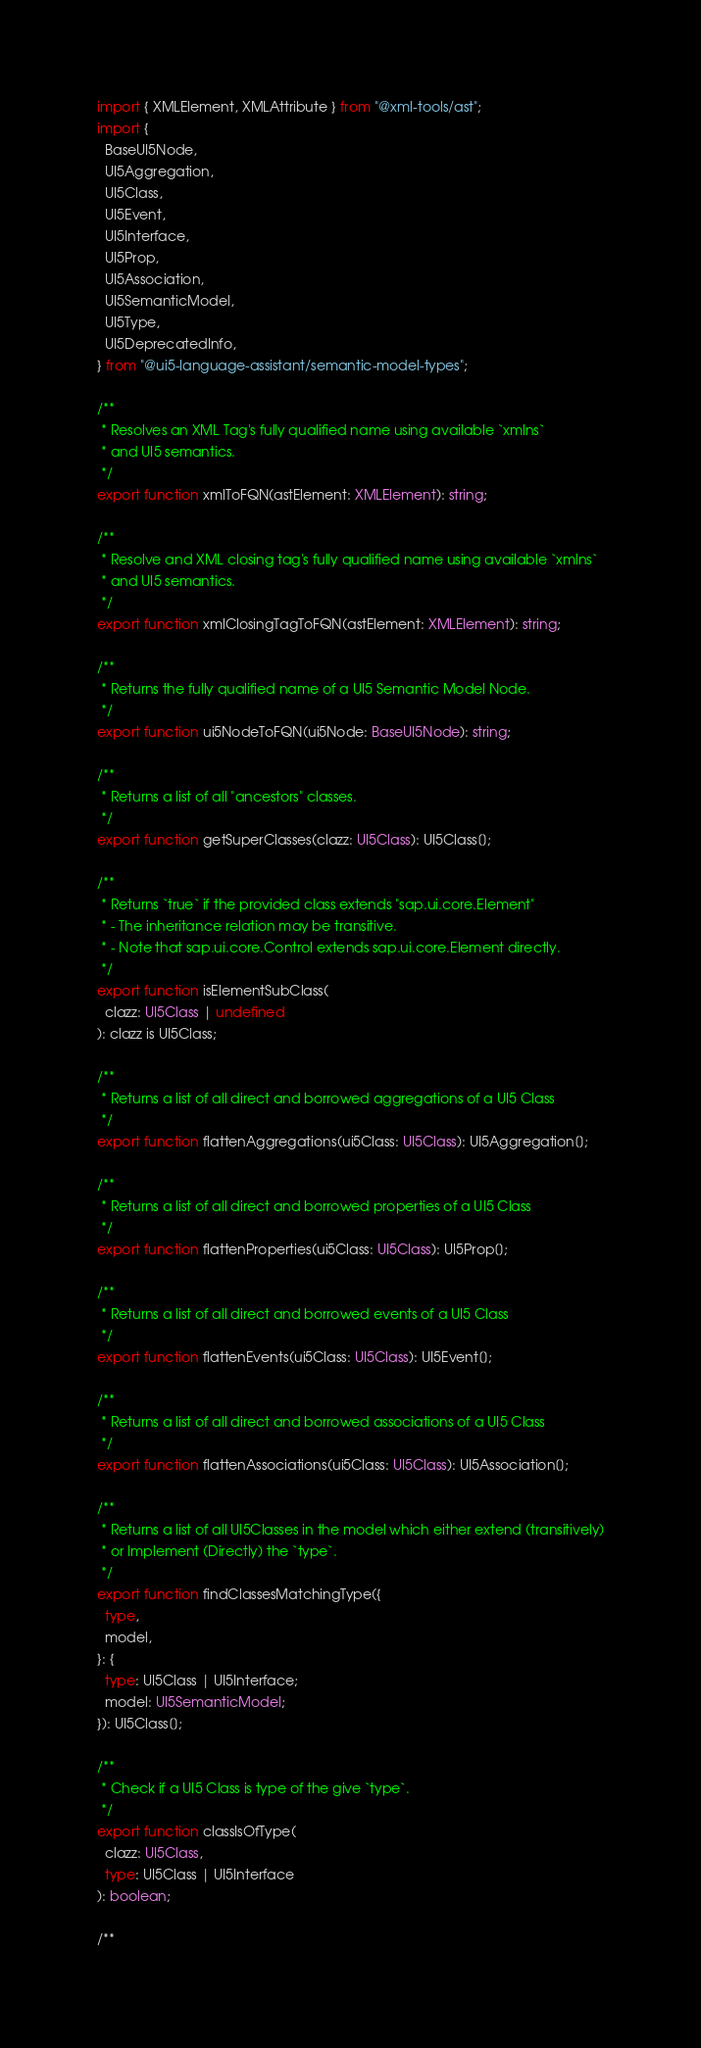<code> <loc_0><loc_0><loc_500><loc_500><_TypeScript_>import { XMLElement, XMLAttribute } from "@xml-tools/ast";
import {
  BaseUI5Node,
  UI5Aggregation,
  UI5Class,
  UI5Event,
  UI5Interface,
  UI5Prop,
  UI5Association,
  UI5SemanticModel,
  UI5Type,
  UI5DeprecatedInfo,
} from "@ui5-language-assistant/semantic-model-types";

/**
 * Resolves an XML Tag's fully qualified name using available `xmlns`
 * and UI5 semantics.
 */
export function xmlToFQN(astElement: XMLElement): string;

/**
 * Resolve and XML closing tag's fully qualified name using available `xmlns`
 * and UI5 semantics.
 */
export function xmlClosingTagToFQN(astElement: XMLElement): string;

/**
 * Returns the fully qualified name of a UI5 Semantic Model Node.
 */
export function ui5NodeToFQN(ui5Node: BaseUI5Node): string;

/**
 * Returns a list of all "ancestors" classes.
 */
export function getSuperClasses(clazz: UI5Class): UI5Class[];

/**
 * Returns `true` if the provided class extends "sap.ui.core.Element"
 * - The inheritance relation may be transitive.
 * - Note that sap.ui.core.Control extends sap.ui.core.Element directly.
 */
export function isElementSubClass(
  clazz: UI5Class | undefined
): clazz is UI5Class;

/**
 * Returns a list of all direct and borrowed aggregations of a UI5 Class
 */
export function flattenAggregations(ui5Class: UI5Class): UI5Aggregation[];

/**
 * Returns a list of all direct and borrowed properties of a UI5 Class
 */
export function flattenProperties(ui5Class: UI5Class): UI5Prop[];

/**
 * Returns a list of all direct and borrowed events of a UI5 Class
 */
export function flattenEvents(ui5Class: UI5Class): UI5Event[];

/**
 * Returns a list of all direct and borrowed associations of a UI5 Class
 */
export function flattenAssociations(ui5Class: UI5Class): UI5Association[];

/**
 * Returns a list of all UI5Classes in the model which either extend (transitively)
 * or Implement (Directly) the `type`.
 */
export function findClassesMatchingType({
  type,
  model,
}: {
  type: UI5Class | UI5Interface;
  model: UI5SemanticModel;
}): UI5Class[];

/**
 * Check if a UI5 Class is type of the give `type`.
 */
export function classIsOfType(
  clazz: UI5Class,
  type: UI5Class | UI5Interface
): boolean;

/**</code> 